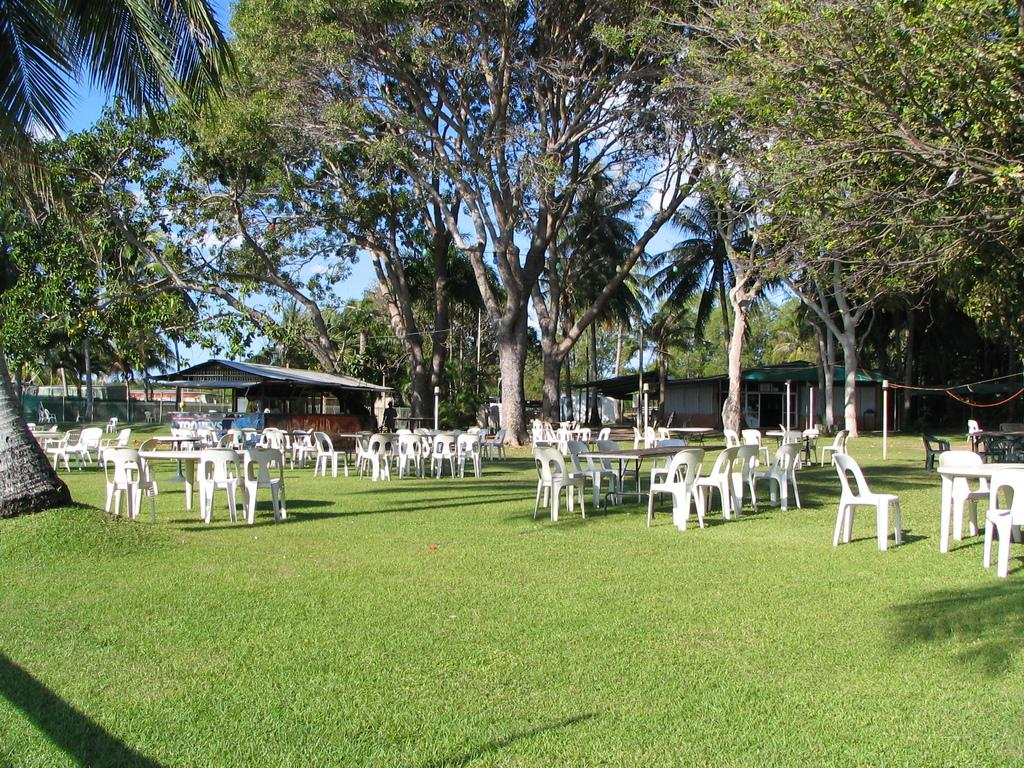What type of furniture is visible in the image? There are tables and white chairs in the image. Where are the tables and chairs located? The tables and chairs are on the grass. What can be seen in the background of the image? There are trees and shacks in the background of the image. Can you see any cobwebs on the tables or chairs in the image? There is no mention of cobwebs in the image, so we cannot determine if they are present or not. 